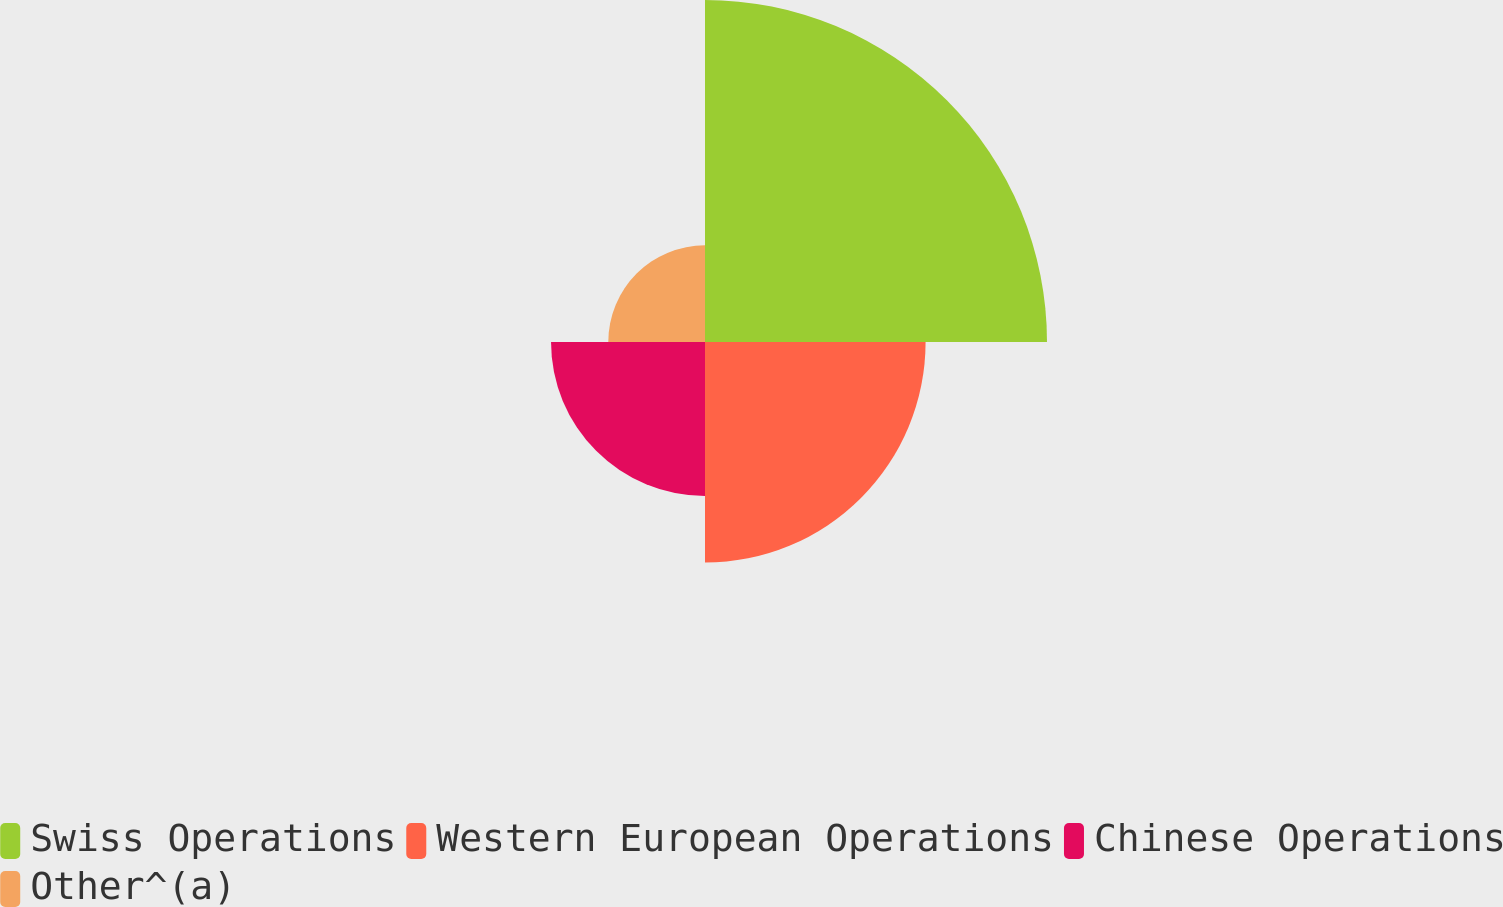Convert chart to OTSL. <chart><loc_0><loc_0><loc_500><loc_500><pie_chart><fcel>Swiss Operations<fcel>Western European Operations<fcel>Chinese Operations<fcel>Other^(a)<nl><fcel>42.05%<fcel>27.12%<fcel>18.93%<fcel>11.89%<nl></chart> 